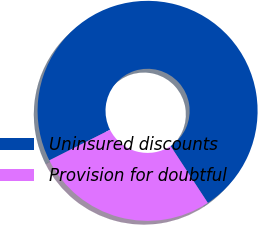<chart> <loc_0><loc_0><loc_500><loc_500><pie_chart><fcel>Uninsured discounts<fcel>Provision for doubtful<nl><fcel>73.21%<fcel>26.79%<nl></chart> 